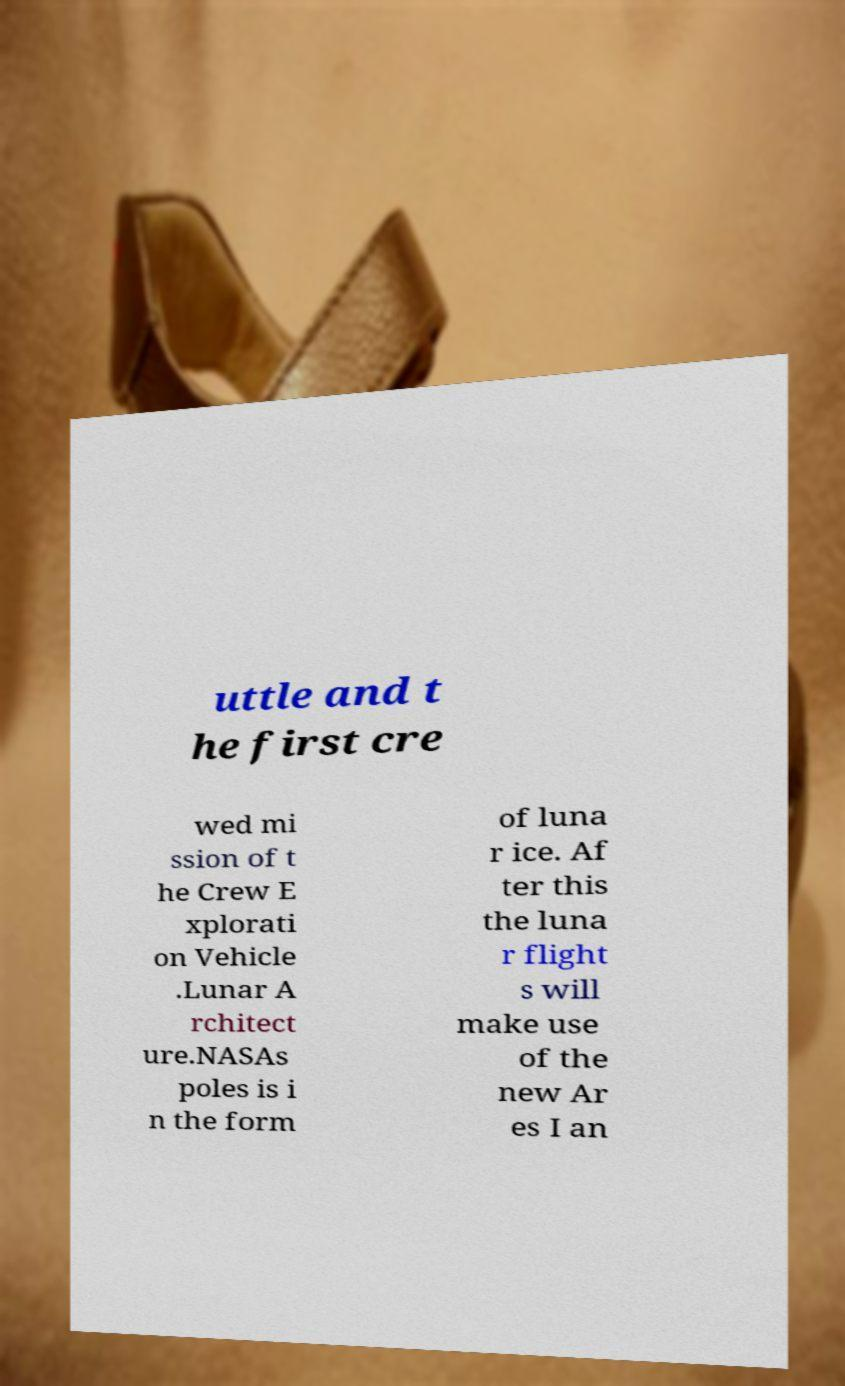Could you assist in decoding the text presented in this image and type it out clearly? uttle and t he first cre wed mi ssion of t he Crew E xplorati on Vehicle .Lunar A rchitect ure.NASAs poles is i n the form of luna r ice. Af ter this the luna r flight s will make use of the new Ar es I an 